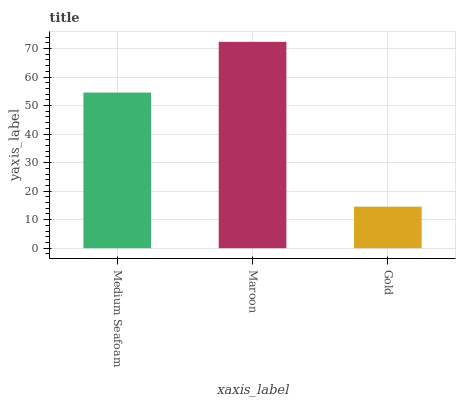Is Maroon the minimum?
Answer yes or no. No. Is Gold the maximum?
Answer yes or no. No. Is Maroon greater than Gold?
Answer yes or no. Yes. Is Gold less than Maroon?
Answer yes or no. Yes. Is Gold greater than Maroon?
Answer yes or no. No. Is Maroon less than Gold?
Answer yes or no. No. Is Medium Seafoam the high median?
Answer yes or no. Yes. Is Medium Seafoam the low median?
Answer yes or no. Yes. Is Maroon the high median?
Answer yes or no. No. Is Maroon the low median?
Answer yes or no. No. 